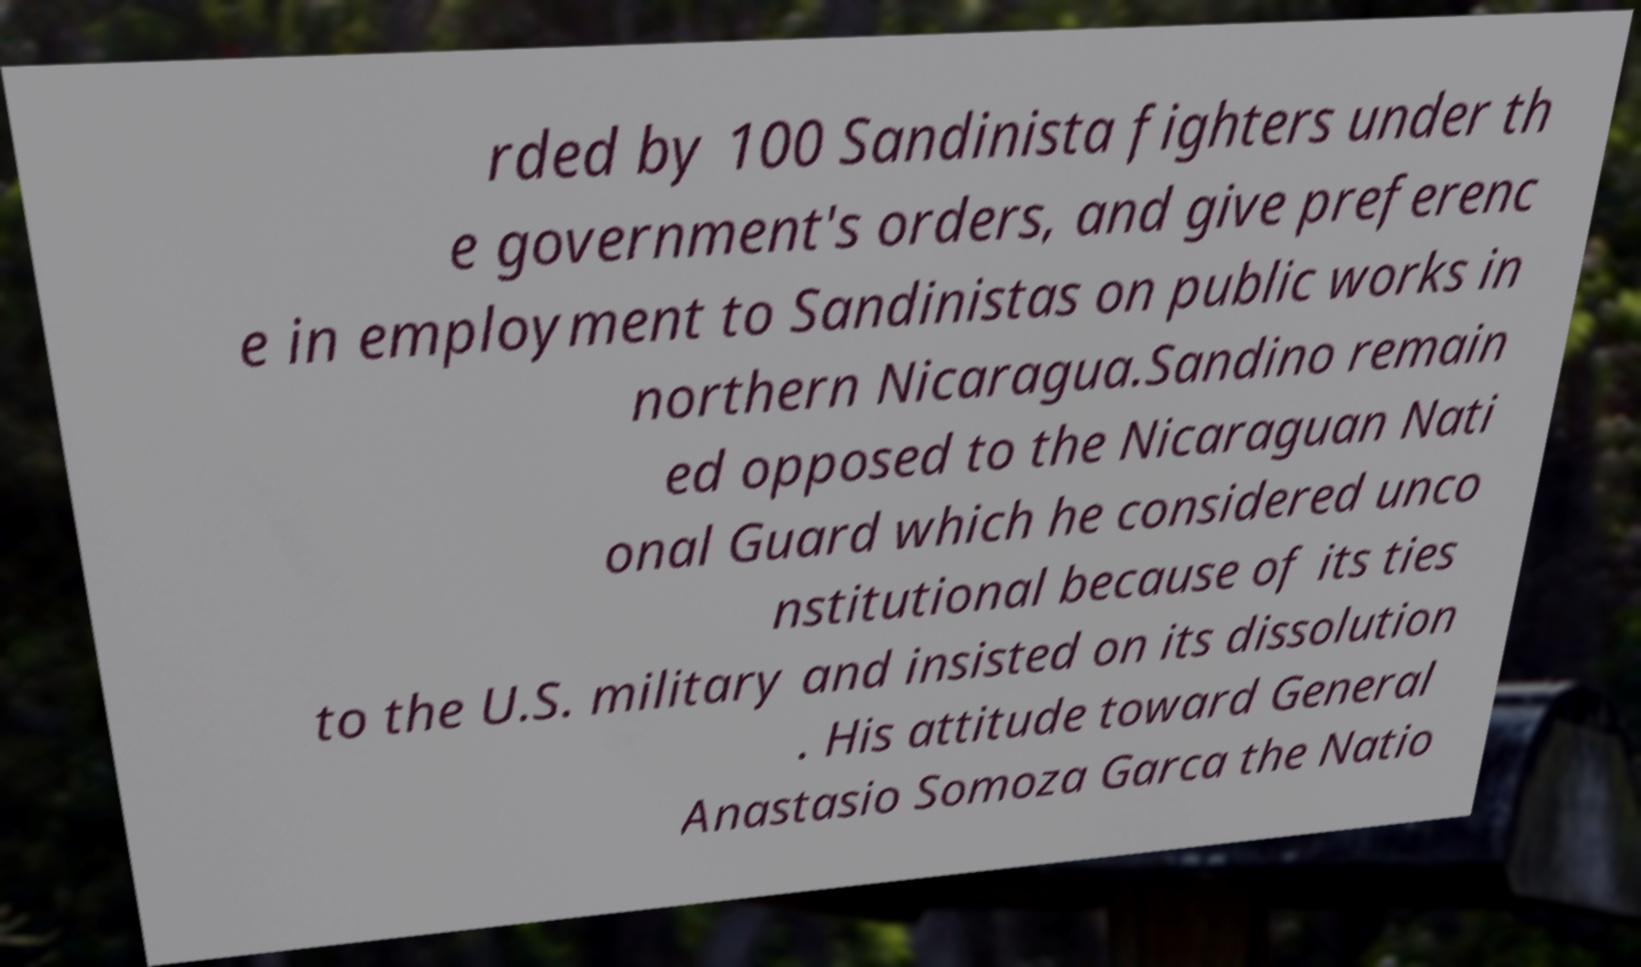I need the written content from this picture converted into text. Can you do that? rded by 100 Sandinista fighters under th e government's orders, and give preferenc e in employment to Sandinistas on public works in northern Nicaragua.Sandino remain ed opposed to the Nicaraguan Nati onal Guard which he considered unco nstitutional because of its ties to the U.S. military and insisted on its dissolution . His attitude toward General Anastasio Somoza Garca the Natio 